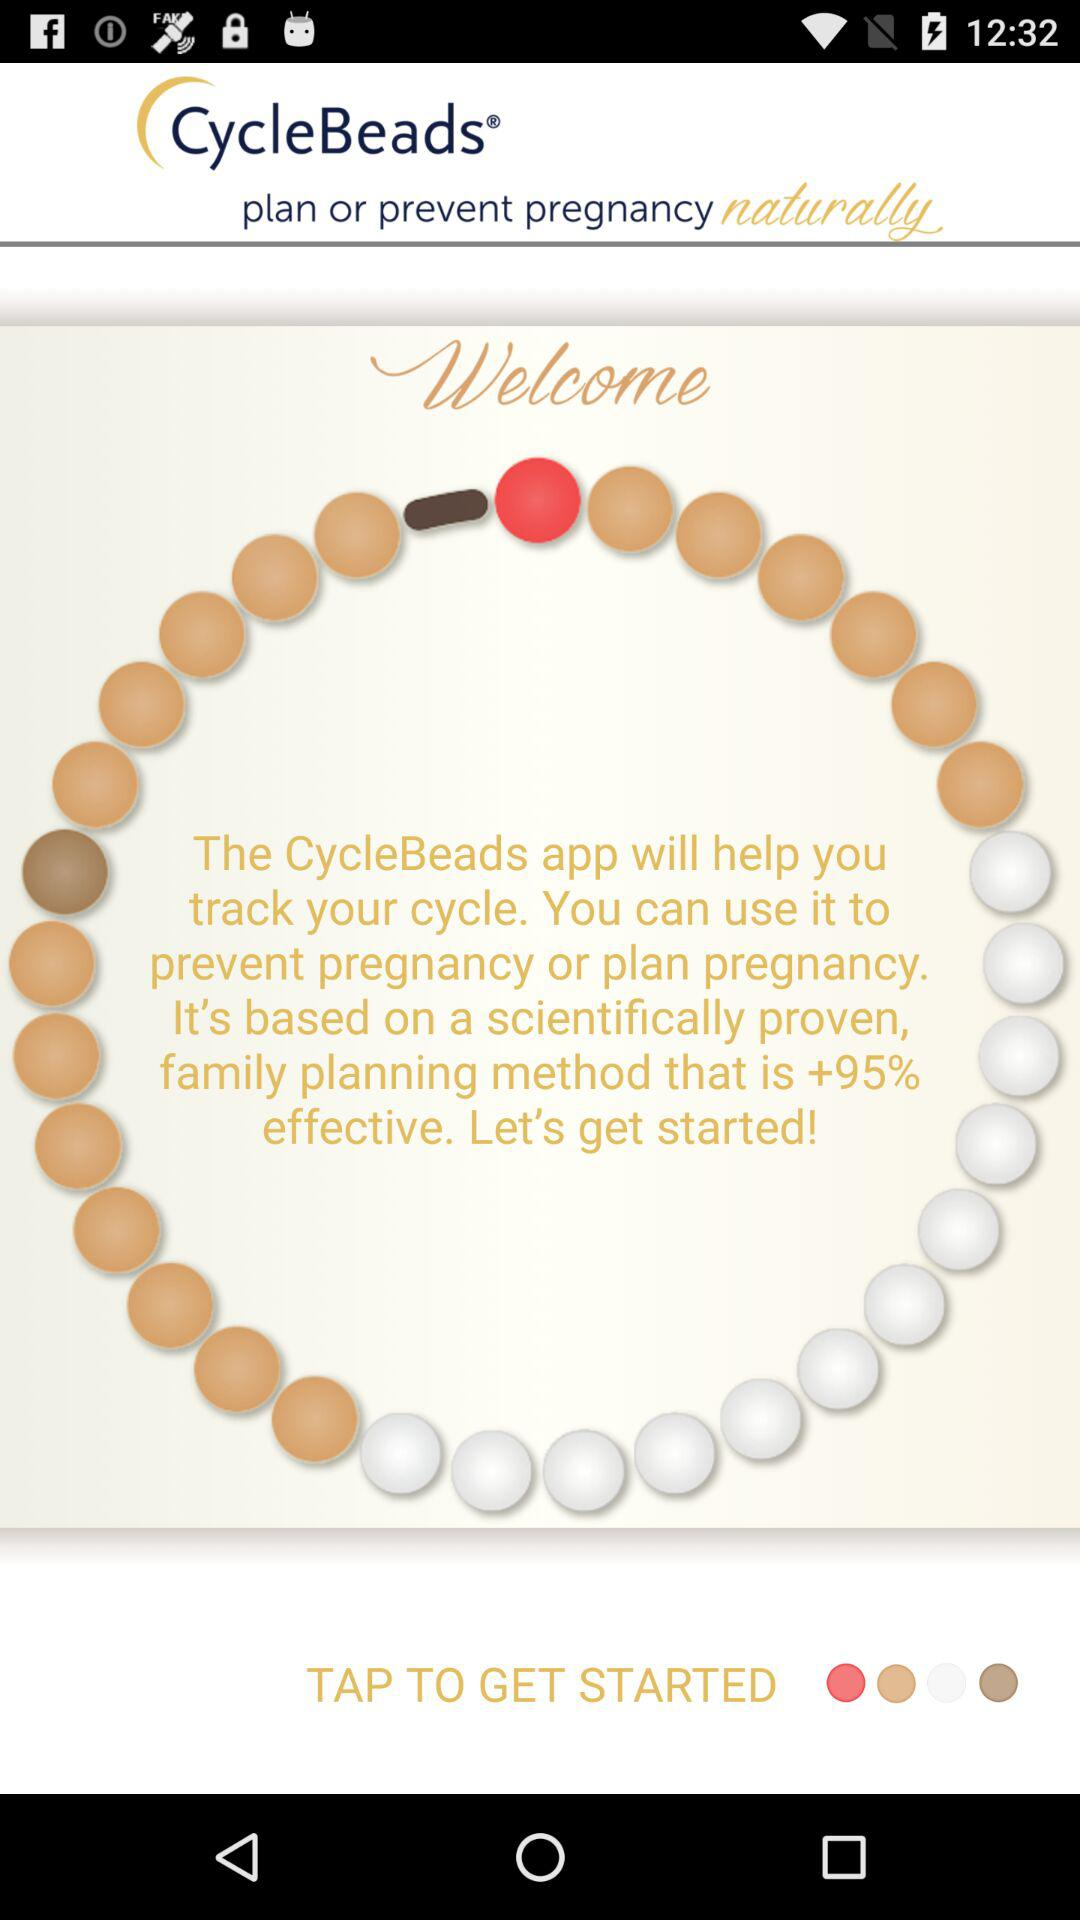Where can CycleBeads be useful? CycleBeads are useful to "prevent pregnancy or plan pregnancy". 